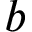<formula> <loc_0><loc_0><loc_500><loc_500>b</formula> 